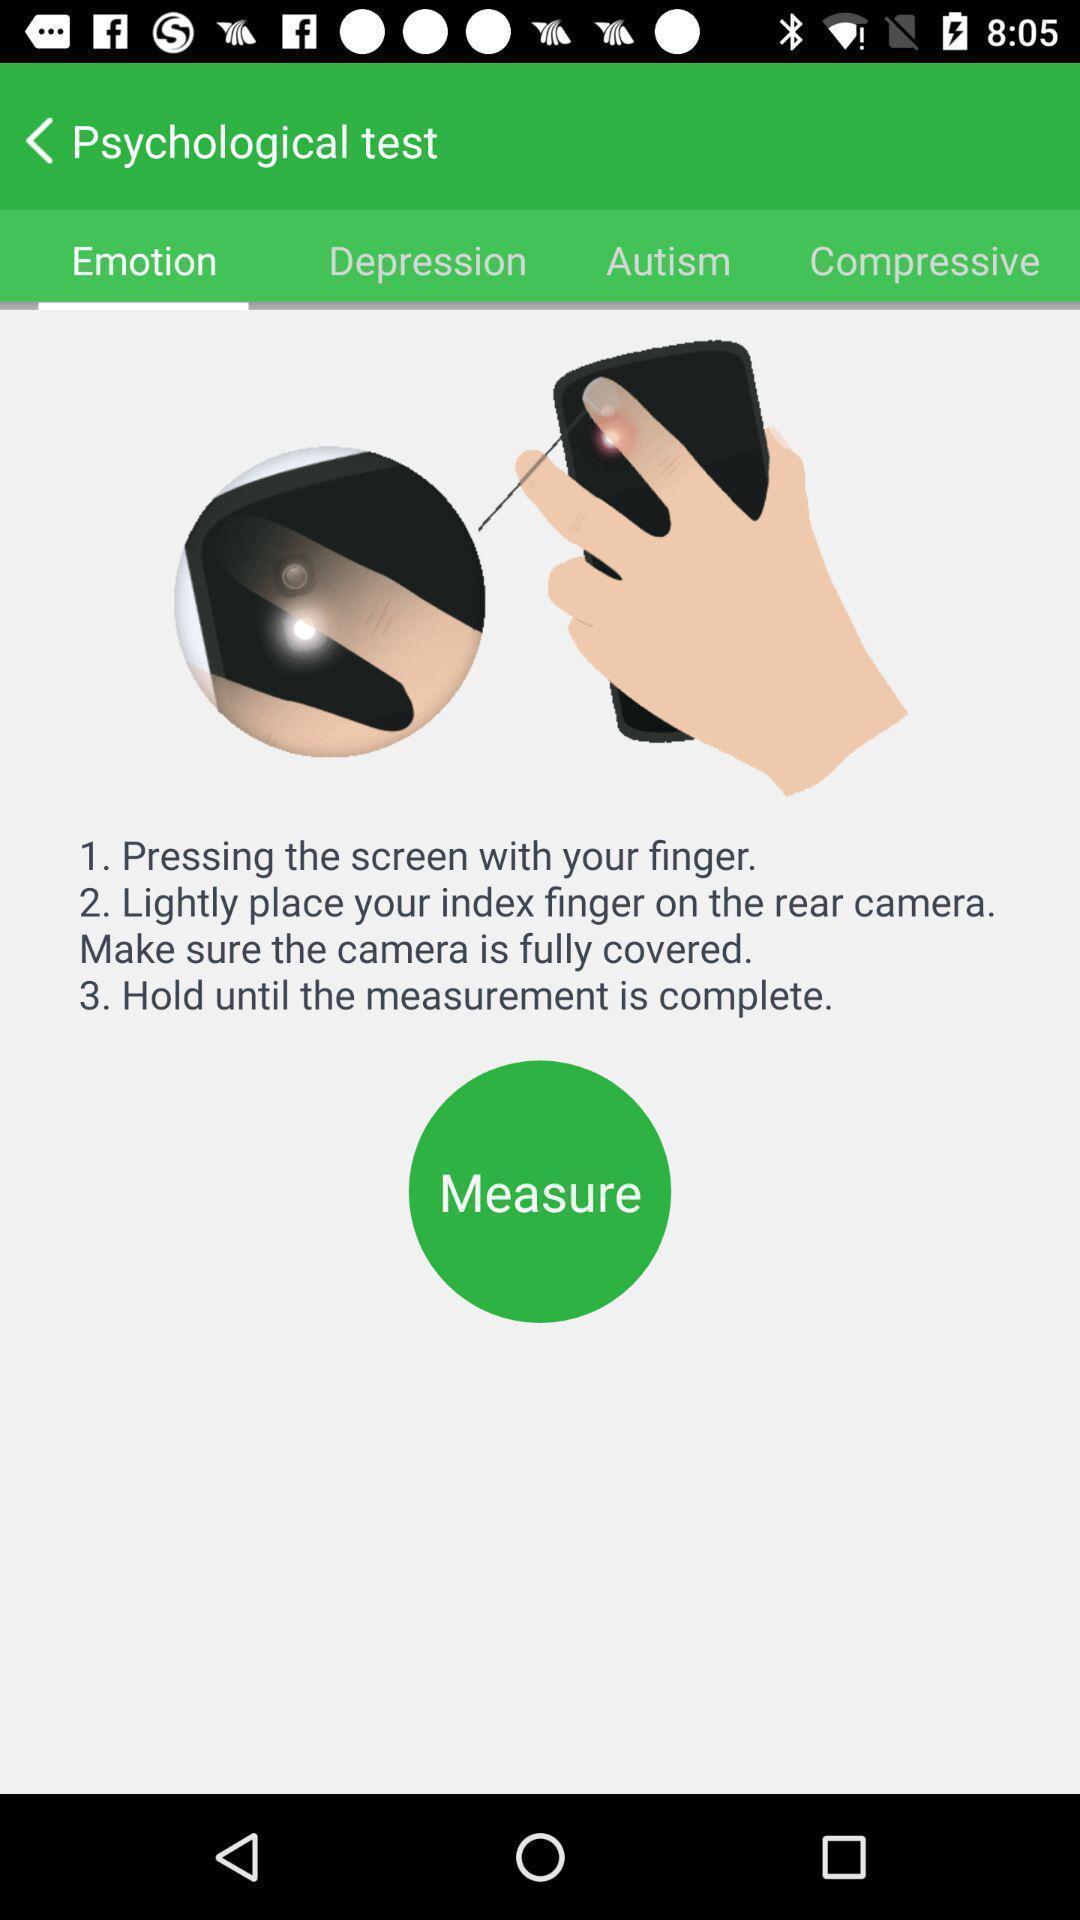Give me a summary of this screen capture. Page for measuring emotions. 